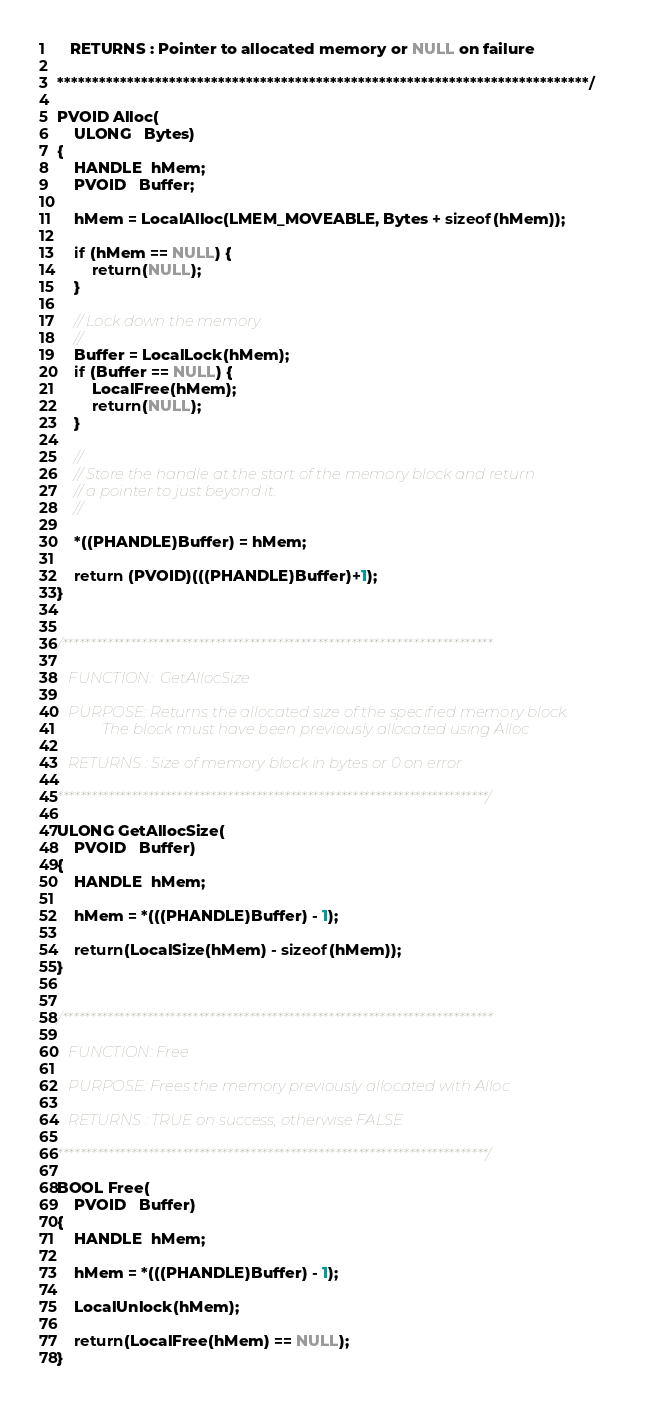<code> <loc_0><loc_0><loc_500><loc_500><_C_>   RETURNS : Pointer to allocated memory or NULL on failure

****************************************************************************/

PVOID Alloc(
    ULONG   Bytes)
{
    HANDLE  hMem;
    PVOID   Buffer;

    hMem = LocalAlloc(LMEM_MOVEABLE, Bytes + sizeof(hMem));

    if (hMem == NULL) {
        return(NULL);
    }

    // Lock down the memory
    //
    Buffer = LocalLock(hMem);
    if (Buffer == NULL) {
        LocalFree(hMem);
        return(NULL);
    }

    //
    // Store the handle at the start of the memory block and return
    // a pointer to just beyond it.
    //

    *((PHANDLE)Buffer) = hMem;

    return (PVOID)(((PHANDLE)Buffer)+1);
}


/****************************************************************************

   FUNCTION:  GetAllocSize

   PURPOSE: Returns the allocated size of the specified memory block.
            The block must have been previously allocated using Alloc

   RETURNS : Size of memory block in bytes or 0 on error

****************************************************************************/

ULONG GetAllocSize(
    PVOID   Buffer)
{
    HANDLE  hMem;

    hMem = *(((PHANDLE)Buffer) - 1);

    return(LocalSize(hMem) - sizeof(hMem));
}


/****************************************************************************

   FUNCTION: Free

   PURPOSE: Frees the memory previously allocated with Alloc

   RETURNS : TRUE on success, otherwise FALSE

****************************************************************************/

BOOL Free(
    PVOID   Buffer)
{
    HANDLE  hMem;

    hMem = *(((PHANDLE)Buffer) - 1);

    LocalUnlock(hMem);

    return(LocalFree(hMem) == NULL);
}

</code> 